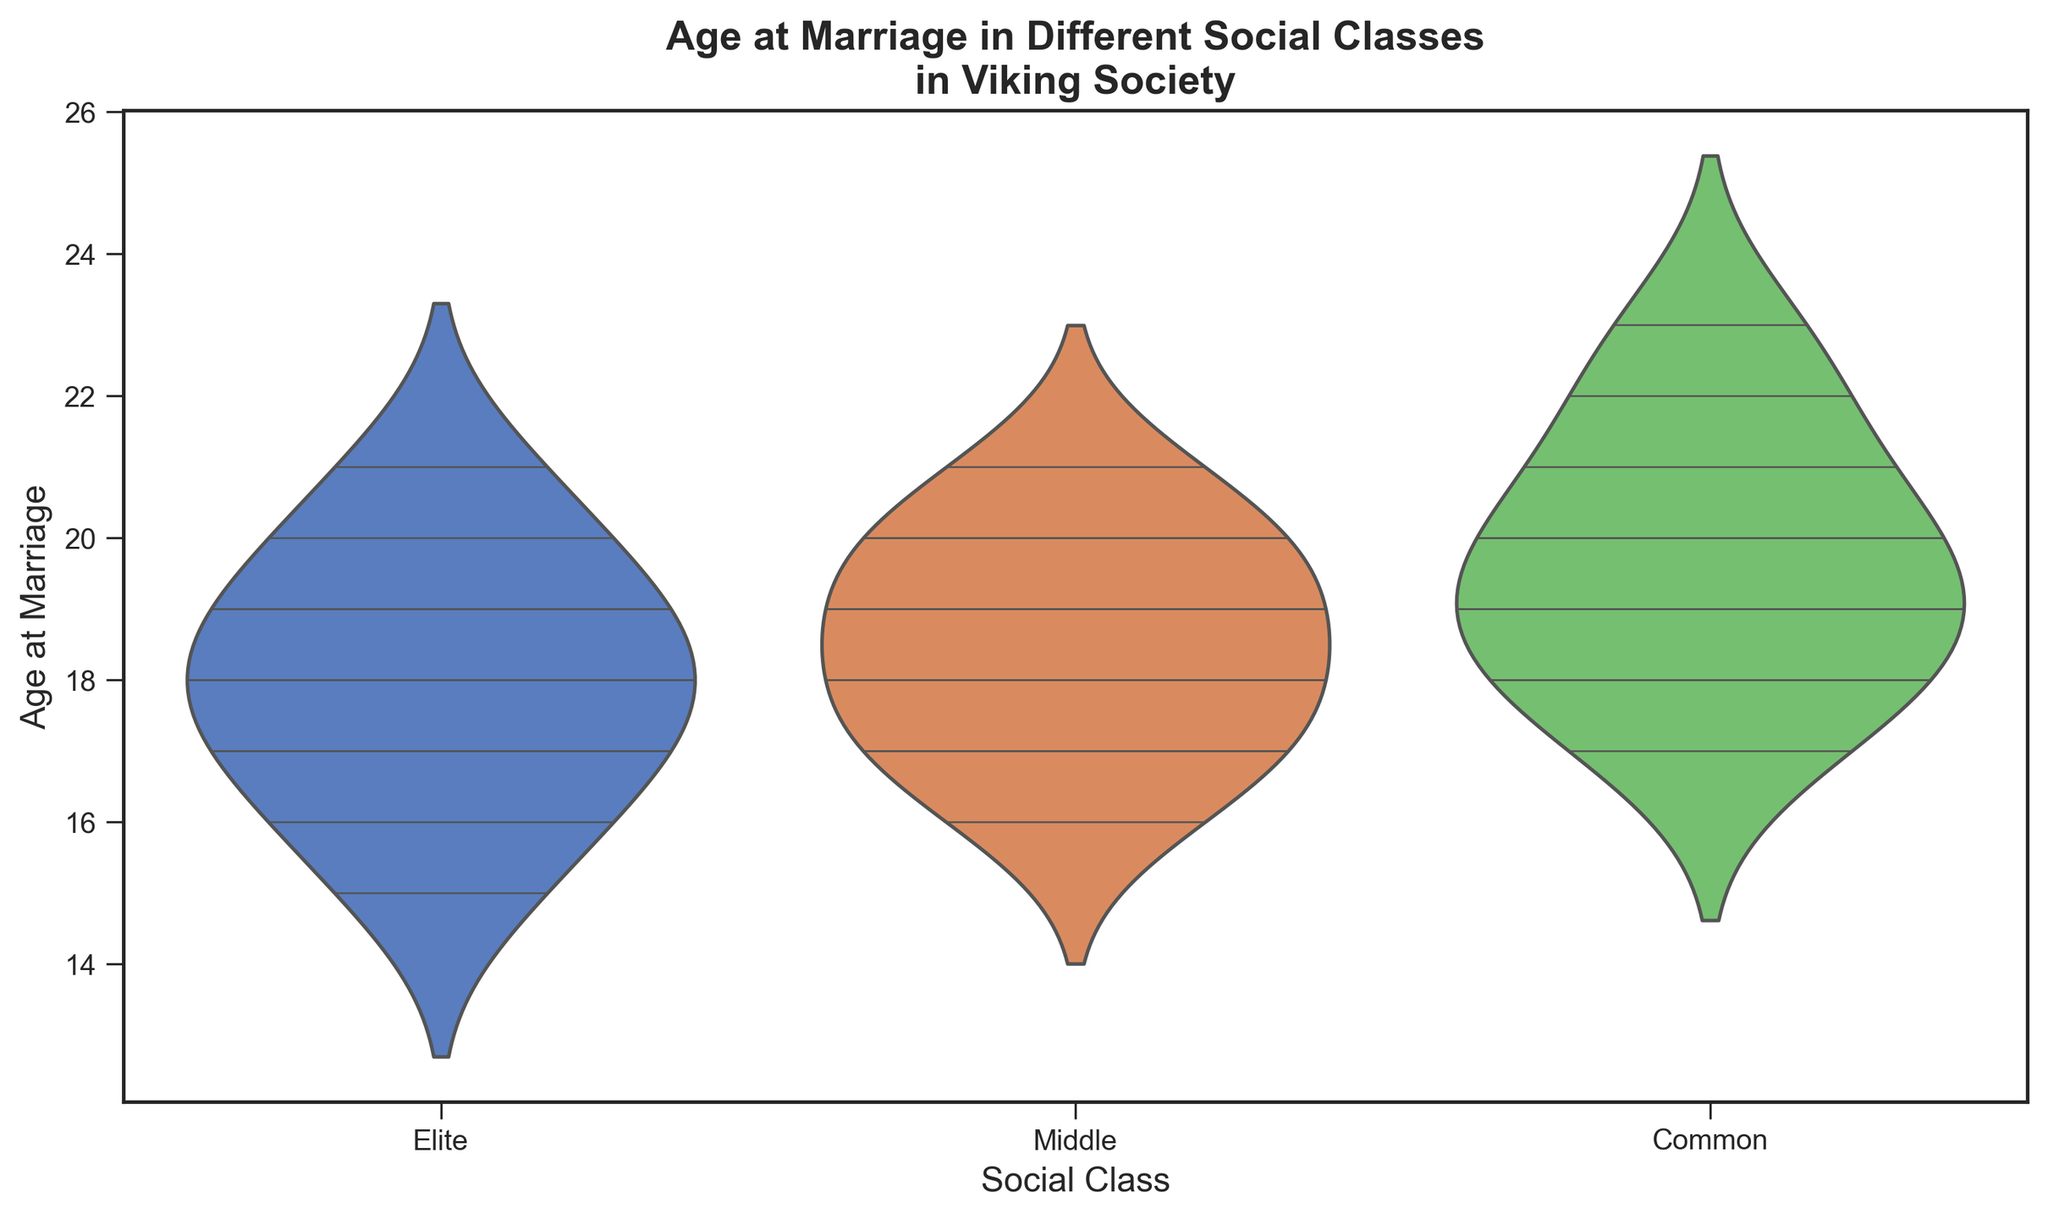What is the most common age at marriage for the "Elite" social class? Looking at the figure, the points within the violin plot indicate where individual data points are. The highest density of points for the "Elite" social class appears around the ages 17 and 18.
Answer: 17 and 18 Which social class has the widest range of ages at marriage? To determine which social class has the widest range, we compare the spread of the violin plots. The "Common" class ranges from 17 to 23, showing the widest age range compared to the other classes.
Answer: Common How does the median age at marriage for the "Middle" class compare to the median age for the "Elite" class? Medians in violin plots can usually be estimated by looking at the points where the density is the highest. The "Middle" class has a median age around 18.5-19, while the "Elite" class has a median around 18-19. They are very close but slightly higher for the "Middle" class.
Answer: Nearly equal Which social class shows the highest variability in age at marriage? Variability can be observed through the width and spread of the violin plot. The "Common" class displays the highest variability as it has a broad distribution and a longer range from 17 to 23.
Answer: Common In which social class do you see children getting married as young as 15? By observing the lower end of each violin plot, it is clear that only the "Elite" class shows marriages at the age of 15.
Answer: Elite What is the maximum age at marriage observed in the "Common" social class? The topmost point in the "Common" class violin plot indicates the maximum age, which is 23.
Answer: 23 Is there a social class with a minimum age of marriage above 15? From the visual attributes, both "Middle" and "Common" classes do not have any individuals getting married below age 16.
Answer: Middle and Common Does any social class have individuals getting married at age 22? The figure shows individual data points in the "Common" class violin plot at age 22, but not in the "Elite" or "Middle" classes.
Answer: Common 